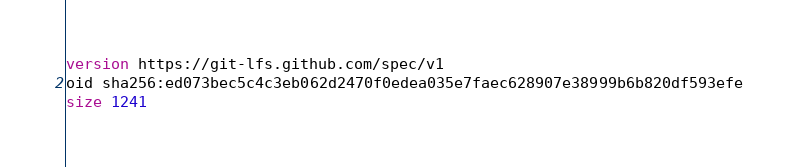Convert code to text. <code><loc_0><loc_0><loc_500><loc_500><_SQL_>version https://git-lfs.github.com/spec/v1
oid sha256:ed073bec5c4c3eb062d2470f0edea035e7faec628907e38999b6b820df593efe
size 1241
</code> 